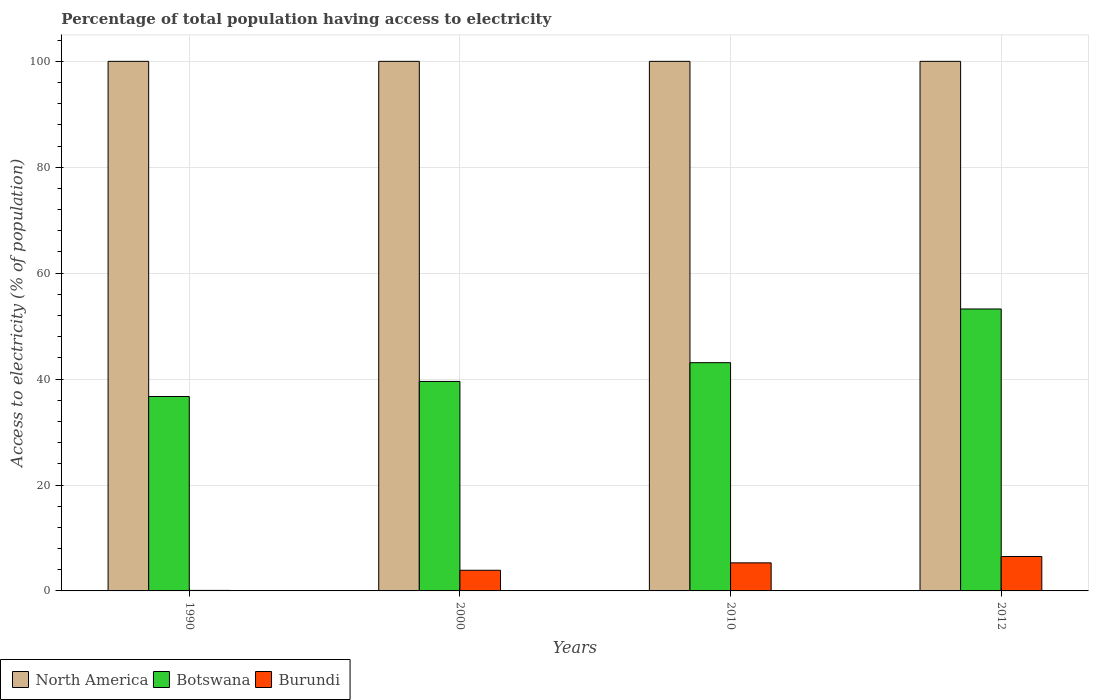How many groups of bars are there?
Keep it short and to the point. 4. Are the number of bars per tick equal to the number of legend labels?
Offer a terse response. Yes. How many bars are there on the 4th tick from the left?
Your answer should be very brief. 3. What is the label of the 2nd group of bars from the left?
Provide a short and direct response. 2000. What is the percentage of population that have access to electricity in Botswana in 2012?
Offer a terse response. 53.24. Across all years, what is the maximum percentage of population that have access to electricity in North America?
Offer a very short reply. 100. Across all years, what is the minimum percentage of population that have access to electricity in Botswana?
Ensure brevity in your answer.  36.72. In which year was the percentage of population that have access to electricity in Burundi minimum?
Offer a terse response. 1990. What is the difference between the percentage of population that have access to electricity in Botswana in 2010 and that in 2012?
Your answer should be very brief. -10.14. What is the difference between the percentage of population that have access to electricity in Botswana in 2000 and the percentage of population that have access to electricity in North America in 1990?
Make the answer very short. -60.44. What is the average percentage of population that have access to electricity in Burundi per year?
Your response must be concise. 3.95. In the year 2010, what is the difference between the percentage of population that have access to electricity in North America and percentage of population that have access to electricity in Botswana?
Provide a short and direct response. 56.9. In how many years, is the percentage of population that have access to electricity in North America greater than 92 %?
Your response must be concise. 4. What is the ratio of the percentage of population that have access to electricity in North America in 1990 to that in 2010?
Keep it short and to the point. 1. What is the difference between the highest and the second highest percentage of population that have access to electricity in Botswana?
Your answer should be very brief. 10.14. Is the sum of the percentage of population that have access to electricity in North America in 2000 and 2010 greater than the maximum percentage of population that have access to electricity in Botswana across all years?
Offer a terse response. Yes. Is it the case that in every year, the sum of the percentage of population that have access to electricity in North America and percentage of population that have access to electricity in Botswana is greater than the percentage of population that have access to electricity in Burundi?
Offer a very short reply. Yes. What is the difference between two consecutive major ticks on the Y-axis?
Your answer should be very brief. 20. Does the graph contain any zero values?
Your response must be concise. No. Does the graph contain grids?
Provide a succinct answer. Yes. Where does the legend appear in the graph?
Keep it short and to the point. Bottom left. How many legend labels are there?
Provide a succinct answer. 3. What is the title of the graph?
Make the answer very short. Percentage of total population having access to electricity. Does "Hungary" appear as one of the legend labels in the graph?
Provide a short and direct response. No. What is the label or title of the Y-axis?
Ensure brevity in your answer.  Access to electricity (% of population). What is the Access to electricity (% of population) in Botswana in 1990?
Your response must be concise. 36.72. What is the Access to electricity (% of population) in Botswana in 2000?
Your response must be concise. 39.56. What is the Access to electricity (% of population) in Burundi in 2000?
Make the answer very short. 3.9. What is the Access to electricity (% of population) of North America in 2010?
Your answer should be very brief. 100. What is the Access to electricity (% of population) of Botswana in 2010?
Ensure brevity in your answer.  43.1. What is the Access to electricity (% of population) in Botswana in 2012?
Provide a succinct answer. 53.24. What is the Access to electricity (% of population) of Burundi in 2012?
Your response must be concise. 6.5. Across all years, what is the maximum Access to electricity (% of population) in Botswana?
Your answer should be compact. 53.24. Across all years, what is the maximum Access to electricity (% of population) in Burundi?
Offer a very short reply. 6.5. Across all years, what is the minimum Access to electricity (% of population) of North America?
Offer a very short reply. 100. Across all years, what is the minimum Access to electricity (% of population) of Botswana?
Offer a very short reply. 36.72. Across all years, what is the minimum Access to electricity (% of population) in Burundi?
Provide a succinct answer. 0.1. What is the total Access to electricity (% of population) in North America in the graph?
Give a very brief answer. 400. What is the total Access to electricity (% of population) of Botswana in the graph?
Offer a terse response. 172.61. What is the total Access to electricity (% of population) in Burundi in the graph?
Your answer should be compact. 15.8. What is the difference between the Access to electricity (% of population) in Botswana in 1990 and that in 2000?
Keep it short and to the point. -2.84. What is the difference between the Access to electricity (% of population) in Botswana in 1990 and that in 2010?
Your answer should be compact. -6.38. What is the difference between the Access to electricity (% of population) of Burundi in 1990 and that in 2010?
Provide a succinct answer. -5.2. What is the difference between the Access to electricity (% of population) in North America in 1990 and that in 2012?
Make the answer very short. 0. What is the difference between the Access to electricity (% of population) in Botswana in 1990 and that in 2012?
Offer a terse response. -16.52. What is the difference between the Access to electricity (% of population) of Botswana in 2000 and that in 2010?
Make the answer very short. -3.54. What is the difference between the Access to electricity (% of population) of Botswana in 2000 and that in 2012?
Your response must be concise. -13.68. What is the difference between the Access to electricity (% of population) of Burundi in 2000 and that in 2012?
Make the answer very short. -2.6. What is the difference between the Access to electricity (% of population) of Botswana in 2010 and that in 2012?
Offer a very short reply. -10.14. What is the difference between the Access to electricity (% of population) of North America in 1990 and the Access to electricity (% of population) of Botswana in 2000?
Ensure brevity in your answer.  60.44. What is the difference between the Access to electricity (% of population) of North America in 1990 and the Access to electricity (% of population) of Burundi in 2000?
Give a very brief answer. 96.1. What is the difference between the Access to electricity (% of population) of Botswana in 1990 and the Access to electricity (% of population) of Burundi in 2000?
Offer a terse response. 32.82. What is the difference between the Access to electricity (% of population) in North America in 1990 and the Access to electricity (% of population) in Botswana in 2010?
Ensure brevity in your answer.  56.9. What is the difference between the Access to electricity (% of population) in North America in 1990 and the Access to electricity (% of population) in Burundi in 2010?
Ensure brevity in your answer.  94.7. What is the difference between the Access to electricity (% of population) in Botswana in 1990 and the Access to electricity (% of population) in Burundi in 2010?
Your answer should be very brief. 31.42. What is the difference between the Access to electricity (% of population) in North America in 1990 and the Access to electricity (% of population) in Botswana in 2012?
Provide a short and direct response. 46.76. What is the difference between the Access to electricity (% of population) in North America in 1990 and the Access to electricity (% of population) in Burundi in 2012?
Your answer should be compact. 93.5. What is the difference between the Access to electricity (% of population) of Botswana in 1990 and the Access to electricity (% of population) of Burundi in 2012?
Provide a short and direct response. 30.22. What is the difference between the Access to electricity (% of population) of North America in 2000 and the Access to electricity (% of population) of Botswana in 2010?
Your answer should be very brief. 56.9. What is the difference between the Access to electricity (% of population) of North America in 2000 and the Access to electricity (% of population) of Burundi in 2010?
Offer a terse response. 94.7. What is the difference between the Access to electricity (% of population) of Botswana in 2000 and the Access to electricity (% of population) of Burundi in 2010?
Offer a very short reply. 34.26. What is the difference between the Access to electricity (% of population) of North America in 2000 and the Access to electricity (% of population) of Botswana in 2012?
Keep it short and to the point. 46.76. What is the difference between the Access to electricity (% of population) of North America in 2000 and the Access to electricity (% of population) of Burundi in 2012?
Your response must be concise. 93.5. What is the difference between the Access to electricity (% of population) in Botswana in 2000 and the Access to electricity (% of population) in Burundi in 2012?
Your answer should be compact. 33.06. What is the difference between the Access to electricity (% of population) in North America in 2010 and the Access to electricity (% of population) in Botswana in 2012?
Your answer should be very brief. 46.76. What is the difference between the Access to electricity (% of population) of North America in 2010 and the Access to electricity (% of population) of Burundi in 2012?
Give a very brief answer. 93.5. What is the difference between the Access to electricity (% of population) in Botswana in 2010 and the Access to electricity (% of population) in Burundi in 2012?
Offer a terse response. 36.6. What is the average Access to electricity (% of population) in Botswana per year?
Provide a short and direct response. 43.15. What is the average Access to electricity (% of population) in Burundi per year?
Your answer should be compact. 3.95. In the year 1990, what is the difference between the Access to electricity (% of population) in North America and Access to electricity (% of population) in Botswana?
Ensure brevity in your answer.  63.28. In the year 1990, what is the difference between the Access to electricity (% of population) of North America and Access to electricity (% of population) of Burundi?
Offer a very short reply. 99.9. In the year 1990, what is the difference between the Access to electricity (% of population) of Botswana and Access to electricity (% of population) of Burundi?
Give a very brief answer. 36.62. In the year 2000, what is the difference between the Access to electricity (% of population) of North America and Access to electricity (% of population) of Botswana?
Make the answer very short. 60.44. In the year 2000, what is the difference between the Access to electricity (% of population) of North America and Access to electricity (% of population) of Burundi?
Provide a short and direct response. 96.1. In the year 2000, what is the difference between the Access to electricity (% of population) in Botswana and Access to electricity (% of population) in Burundi?
Give a very brief answer. 35.66. In the year 2010, what is the difference between the Access to electricity (% of population) of North America and Access to electricity (% of population) of Botswana?
Provide a succinct answer. 56.9. In the year 2010, what is the difference between the Access to electricity (% of population) of North America and Access to electricity (% of population) of Burundi?
Offer a terse response. 94.7. In the year 2010, what is the difference between the Access to electricity (% of population) in Botswana and Access to electricity (% of population) in Burundi?
Make the answer very short. 37.8. In the year 2012, what is the difference between the Access to electricity (% of population) in North America and Access to electricity (% of population) in Botswana?
Offer a very short reply. 46.76. In the year 2012, what is the difference between the Access to electricity (% of population) of North America and Access to electricity (% of population) of Burundi?
Make the answer very short. 93.5. In the year 2012, what is the difference between the Access to electricity (% of population) of Botswana and Access to electricity (% of population) of Burundi?
Your answer should be compact. 46.74. What is the ratio of the Access to electricity (% of population) in Botswana in 1990 to that in 2000?
Provide a succinct answer. 0.93. What is the ratio of the Access to electricity (% of population) of Burundi in 1990 to that in 2000?
Give a very brief answer. 0.03. What is the ratio of the Access to electricity (% of population) of North America in 1990 to that in 2010?
Make the answer very short. 1. What is the ratio of the Access to electricity (% of population) in Botswana in 1990 to that in 2010?
Offer a very short reply. 0.85. What is the ratio of the Access to electricity (% of population) in Burundi in 1990 to that in 2010?
Give a very brief answer. 0.02. What is the ratio of the Access to electricity (% of population) in North America in 1990 to that in 2012?
Offer a very short reply. 1. What is the ratio of the Access to electricity (% of population) of Botswana in 1990 to that in 2012?
Make the answer very short. 0.69. What is the ratio of the Access to electricity (% of population) in Burundi in 1990 to that in 2012?
Make the answer very short. 0.02. What is the ratio of the Access to electricity (% of population) in North America in 2000 to that in 2010?
Keep it short and to the point. 1. What is the ratio of the Access to electricity (% of population) of Botswana in 2000 to that in 2010?
Give a very brief answer. 0.92. What is the ratio of the Access to electricity (% of population) in Burundi in 2000 to that in 2010?
Make the answer very short. 0.74. What is the ratio of the Access to electricity (% of population) of Botswana in 2000 to that in 2012?
Ensure brevity in your answer.  0.74. What is the ratio of the Access to electricity (% of population) of Burundi in 2000 to that in 2012?
Provide a succinct answer. 0.6. What is the ratio of the Access to electricity (% of population) in North America in 2010 to that in 2012?
Provide a short and direct response. 1. What is the ratio of the Access to electricity (% of population) in Botswana in 2010 to that in 2012?
Provide a short and direct response. 0.81. What is the ratio of the Access to electricity (% of population) in Burundi in 2010 to that in 2012?
Make the answer very short. 0.82. What is the difference between the highest and the second highest Access to electricity (% of population) in Botswana?
Provide a succinct answer. 10.14. What is the difference between the highest and the second highest Access to electricity (% of population) in Burundi?
Make the answer very short. 1.2. What is the difference between the highest and the lowest Access to electricity (% of population) in Botswana?
Your answer should be compact. 16.52. 